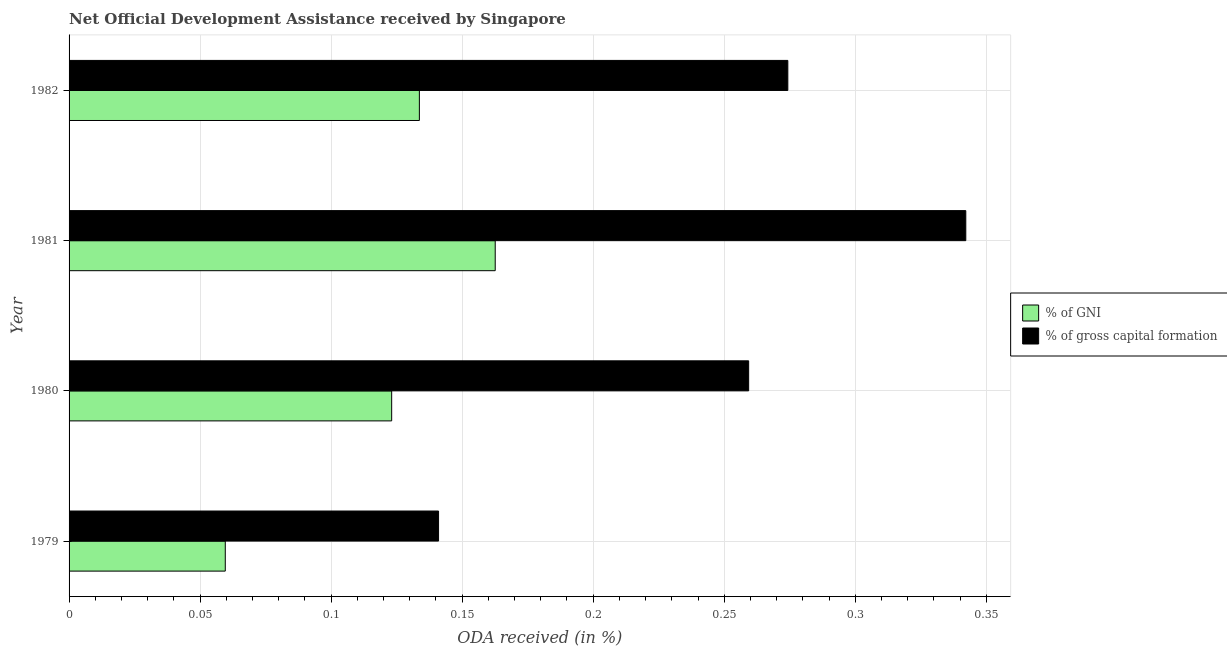How many different coloured bars are there?
Ensure brevity in your answer.  2. How many groups of bars are there?
Your answer should be compact. 4. How many bars are there on the 1st tick from the top?
Make the answer very short. 2. How many bars are there on the 2nd tick from the bottom?
Your response must be concise. 2. What is the oda received as percentage of gni in 1982?
Offer a terse response. 0.13. Across all years, what is the maximum oda received as percentage of gni?
Your answer should be very brief. 0.16. Across all years, what is the minimum oda received as percentage of gni?
Keep it short and to the point. 0.06. In which year was the oda received as percentage of gross capital formation minimum?
Offer a very short reply. 1979. What is the total oda received as percentage of gross capital formation in the graph?
Give a very brief answer. 1.02. What is the difference between the oda received as percentage of gni in 1979 and that in 1981?
Provide a succinct answer. -0.1. What is the difference between the oda received as percentage of gni in 1979 and the oda received as percentage of gross capital formation in 1982?
Make the answer very short. -0.21. What is the average oda received as percentage of gni per year?
Offer a terse response. 0.12. In the year 1980, what is the difference between the oda received as percentage of gross capital formation and oda received as percentage of gni?
Offer a very short reply. 0.14. In how many years, is the oda received as percentage of gross capital formation greater than 0.33000000000000007 %?
Give a very brief answer. 1. What is the ratio of the oda received as percentage of gni in 1979 to that in 1980?
Keep it short and to the point. 0.48. Is the oda received as percentage of gni in 1979 less than that in 1981?
Keep it short and to the point. Yes. Is the difference between the oda received as percentage of gross capital formation in 1979 and 1982 greater than the difference between the oda received as percentage of gni in 1979 and 1982?
Provide a short and direct response. No. What is the difference between the highest and the second highest oda received as percentage of gni?
Offer a terse response. 0.03. Is the sum of the oda received as percentage of gni in 1980 and 1981 greater than the maximum oda received as percentage of gross capital formation across all years?
Your response must be concise. No. What does the 1st bar from the top in 1979 represents?
Make the answer very short. % of gross capital formation. What does the 2nd bar from the bottom in 1979 represents?
Provide a succinct answer. % of gross capital formation. Are all the bars in the graph horizontal?
Make the answer very short. Yes. What is the difference between two consecutive major ticks on the X-axis?
Offer a very short reply. 0.05. Are the values on the major ticks of X-axis written in scientific E-notation?
Ensure brevity in your answer.  No. Where does the legend appear in the graph?
Your answer should be compact. Center right. What is the title of the graph?
Keep it short and to the point. Net Official Development Assistance received by Singapore. What is the label or title of the X-axis?
Your response must be concise. ODA received (in %). What is the label or title of the Y-axis?
Offer a very short reply. Year. What is the ODA received (in %) in % of GNI in 1979?
Make the answer very short. 0.06. What is the ODA received (in %) in % of gross capital formation in 1979?
Give a very brief answer. 0.14. What is the ODA received (in %) of % of GNI in 1980?
Make the answer very short. 0.12. What is the ODA received (in %) of % of gross capital formation in 1980?
Ensure brevity in your answer.  0.26. What is the ODA received (in %) in % of GNI in 1981?
Provide a succinct answer. 0.16. What is the ODA received (in %) in % of gross capital formation in 1981?
Your response must be concise. 0.34. What is the ODA received (in %) of % of GNI in 1982?
Your answer should be very brief. 0.13. What is the ODA received (in %) of % of gross capital formation in 1982?
Keep it short and to the point. 0.27. Across all years, what is the maximum ODA received (in %) of % of GNI?
Make the answer very short. 0.16. Across all years, what is the maximum ODA received (in %) of % of gross capital formation?
Make the answer very short. 0.34. Across all years, what is the minimum ODA received (in %) in % of GNI?
Your answer should be very brief. 0.06. Across all years, what is the minimum ODA received (in %) in % of gross capital formation?
Make the answer very short. 0.14. What is the total ODA received (in %) in % of GNI in the graph?
Your answer should be very brief. 0.48. What is the total ODA received (in %) of % of gross capital formation in the graph?
Make the answer very short. 1.02. What is the difference between the ODA received (in %) of % of GNI in 1979 and that in 1980?
Your response must be concise. -0.06. What is the difference between the ODA received (in %) of % of gross capital formation in 1979 and that in 1980?
Keep it short and to the point. -0.12. What is the difference between the ODA received (in %) of % of GNI in 1979 and that in 1981?
Provide a succinct answer. -0.1. What is the difference between the ODA received (in %) in % of gross capital formation in 1979 and that in 1981?
Your answer should be compact. -0.2. What is the difference between the ODA received (in %) of % of GNI in 1979 and that in 1982?
Offer a terse response. -0.07. What is the difference between the ODA received (in %) of % of gross capital formation in 1979 and that in 1982?
Keep it short and to the point. -0.13. What is the difference between the ODA received (in %) of % of GNI in 1980 and that in 1981?
Offer a terse response. -0.04. What is the difference between the ODA received (in %) of % of gross capital formation in 1980 and that in 1981?
Give a very brief answer. -0.08. What is the difference between the ODA received (in %) in % of GNI in 1980 and that in 1982?
Your answer should be compact. -0.01. What is the difference between the ODA received (in %) of % of gross capital formation in 1980 and that in 1982?
Ensure brevity in your answer.  -0.01. What is the difference between the ODA received (in %) in % of GNI in 1981 and that in 1982?
Offer a very short reply. 0.03. What is the difference between the ODA received (in %) of % of gross capital formation in 1981 and that in 1982?
Keep it short and to the point. 0.07. What is the difference between the ODA received (in %) in % of GNI in 1979 and the ODA received (in %) in % of gross capital formation in 1980?
Provide a succinct answer. -0.2. What is the difference between the ODA received (in %) of % of GNI in 1979 and the ODA received (in %) of % of gross capital formation in 1981?
Ensure brevity in your answer.  -0.28. What is the difference between the ODA received (in %) in % of GNI in 1979 and the ODA received (in %) in % of gross capital formation in 1982?
Ensure brevity in your answer.  -0.21. What is the difference between the ODA received (in %) of % of GNI in 1980 and the ODA received (in %) of % of gross capital formation in 1981?
Your answer should be very brief. -0.22. What is the difference between the ODA received (in %) in % of GNI in 1980 and the ODA received (in %) in % of gross capital formation in 1982?
Offer a very short reply. -0.15. What is the difference between the ODA received (in %) of % of GNI in 1981 and the ODA received (in %) of % of gross capital formation in 1982?
Keep it short and to the point. -0.11. What is the average ODA received (in %) in % of GNI per year?
Keep it short and to the point. 0.12. What is the average ODA received (in %) in % of gross capital formation per year?
Your response must be concise. 0.25. In the year 1979, what is the difference between the ODA received (in %) in % of GNI and ODA received (in %) in % of gross capital formation?
Ensure brevity in your answer.  -0.08. In the year 1980, what is the difference between the ODA received (in %) in % of GNI and ODA received (in %) in % of gross capital formation?
Provide a succinct answer. -0.14. In the year 1981, what is the difference between the ODA received (in %) in % of GNI and ODA received (in %) in % of gross capital formation?
Ensure brevity in your answer.  -0.18. In the year 1982, what is the difference between the ODA received (in %) of % of GNI and ODA received (in %) of % of gross capital formation?
Offer a terse response. -0.14. What is the ratio of the ODA received (in %) in % of GNI in 1979 to that in 1980?
Ensure brevity in your answer.  0.48. What is the ratio of the ODA received (in %) in % of gross capital formation in 1979 to that in 1980?
Keep it short and to the point. 0.54. What is the ratio of the ODA received (in %) in % of GNI in 1979 to that in 1981?
Ensure brevity in your answer.  0.37. What is the ratio of the ODA received (in %) of % of gross capital formation in 1979 to that in 1981?
Keep it short and to the point. 0.41. What is the ratio of the ODA received (in %) in % of GNI in 1979 to that in 1982?
Your answer should be very brief. 0.45. What is the ratio of the ODA received (in %) of % of gross capital formation in 1979 to that in 1982?
Make the answer very short. 0.51. What is the ratio of the ODA received (in %) in % of GNI in 1980 to that in 1981?
Your answer should be very brief. 0.76. What is the ratio of the ODA received (in %) in % of gross capital formation in 1980 to that in 1981?
Make the answer very short. 0.76. What is the ratio of the ODA received (in %) of % of GNI in 1980 to that in 1982?
Your response must be concise. 0.92. What is the ratio of the ODA received (in %) of % of gross capital formation in 1980 to that in 1982?
Offer a very short reply. 0.95. What is the ratio of the ODA received (in %) in % of GNI in 1981 to that in 1982?
Offer a very short reply. 1.22. What is the ratio of the ODA received (in %) of % of gross capital formation in 1981 to that in 1982?
Your answer should be compact. 1.25. What is the difference between the highest and the second highest ODA received (in %) in % of GNI?
Provide a succinct answer. 0.03. What is the difference between the highest and the second highest ODA received (in %) of % of gross capital formation?
Offer a very short reply. 0.07. What is the difference between the highest and the lowest ODA received (in %) of % of GNI?
Ensure brevity in your answer.  0.1. What is the difference between the highest and the lowest ODA received (in %) in % of gross capital formation?
Offer a terse response. 0.2. 